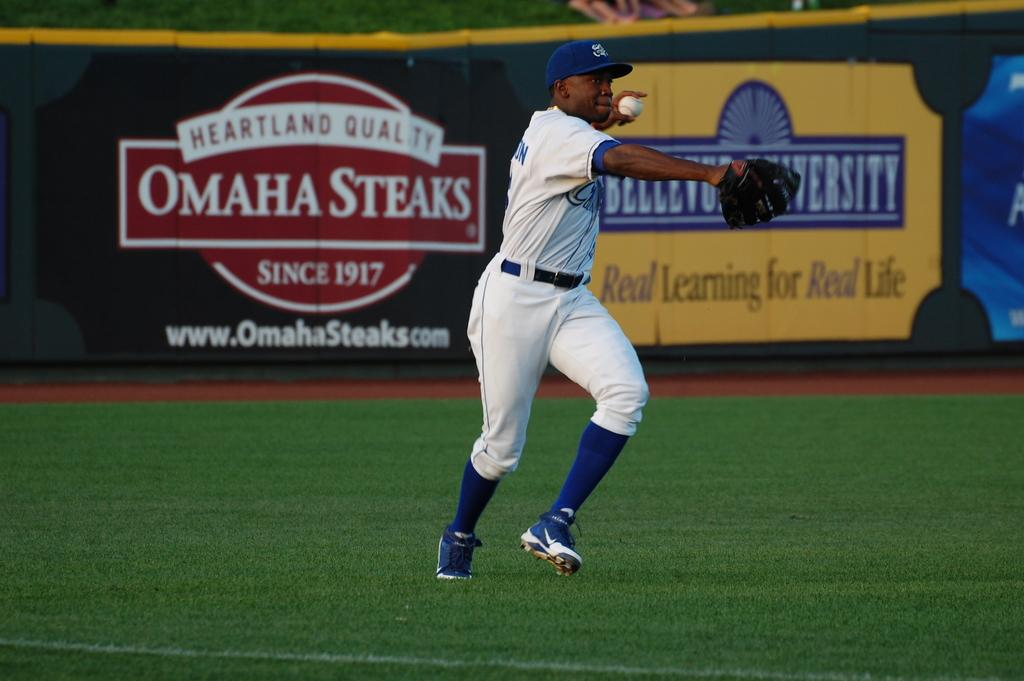<image>
Relay a brief, clear account of the picture shown. A baseball player gets ready to throw a ball in front of an Omaha Steaks advertisement. 